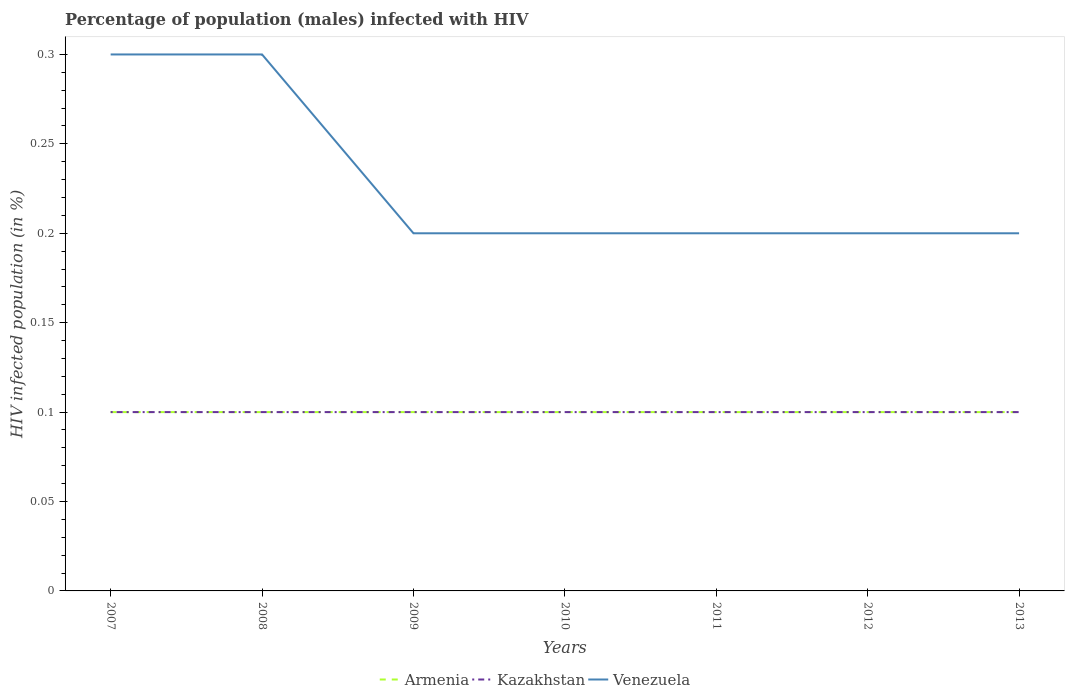Does the line corresponding to Venezuela intersect with the line corresponding to Kazakhstan?
Provide a succinct answer. No. In which year was the percentage of HIV infected male population in Armenia maximum?
Ensure brevity in your answer.  2007. Is the percentage of HIV infected male population in Venezuela strictly greater than the percentage of HIV infected male population in Armenia over the years?
Provide a short and direct response. No. How many lines are there?
Offer a very short reply. 3. How many years are there in the graph?
Provide a short and direct response. 7. Does the graph contain any zero values?
Offer a terse response. No. Does the graph contain grids?
Your answer should be compact. No. What is the title of the graph?
Keep it short and to the point. Percentage of population (males) infected with HIV. Does "Afghanistan" appear as one of the legend labels in the graph?
Your answer should be compact. No. What is the label or title of the Y-axis?
Keep it short and to the point. HIV infected population (in %). What is the HIV infected population (in %) in Armenia in 2007?
Your answer should be very brief. 0.1. What is the HIV infected population (in %) of Kazakhstan in 2007?
Offer a very short reply. 0.1. What is the HIV infected population (in %) of Venezuela in 2007?
Make the answer very short. 0.3. What is the HIV infected population (in %) of Armenia in 2008?
Provide a succinct answer. 0.1. What is the HIV infected population (in %) of Venezuela in 2008?
Your answer should be very brief. 0.3. What is the HIV infected population (in %) of Kazakhstan in 2010?
Offer a terse response. 0.1. What is the HIV infected population (in %) of Venezuela in 2010?
Your answer should be compact. 0.2. What is the HIV infected population (in %) in Kazakhstan in 2011?
Offer a terse response. 0.1. What is the HIV infected population (in %) of Kazakhstan in 2012?
Your response must be concise. 0.1. What is the HIV infected population (in %) in Kazakhstan in 2013?
Ensure brevity in your answer.  0.1. Across all years, what is the maximum HIV infected population (in %) in Kazakhstan?
Make the answer very short. 0.1. Across all years, what is the minimum HIV infected population (in %) of Venezuela?
Make the answer very short. 0.2. What is the total HIV infected population (in %) in Kazakhstan in the graph?
Ensure brevity in your answer.  0.7. What is the total HIV infected population (in %) in Venezuela in the graph?
Your response must be concise. 1.6. What is the difference between the HIV infected population (in %) of Armenia in 2007 and that in 2009?
Provide a short and direct response. 0. What is the difference between the HIV infected population (in %) in Kazakhstan in 2007 and that in 2009?
Your response must be concise. 0. What is the difference between the HIV infected population (in %) in Venezuela in 2007 and that in 2009?
Offer a very short reply. 0.1. What is the difference between the HIV infected population (in %) in Armenia in 2007 and that in 2010?
Provide a short and direct response. 0. What is the difference between the HIV infected population (in %) of Armenia in 2007 and that in 2011?
Provide a short and direct response. 0. What is the difference between the HIV infected population (in %) of Venezuela in 2007 and that in 2012?
Provide a succinct answer. 0.1. What is the difference between the HIV infected population (in %) in Armenia in 2007 and that in 2013?
Offer a very short reply. 0. What is the difference between the HIV infected population (in %) in Kazakhstan in 2007 and that in 2013?
Make the answer very short. 0. What is the difference between the HIV infected population (in %) in Armenia in 2008 and that in 2009?
Your response must be concise. 0. What is the difference between the HIV infected population (in %) in Venezuela in 2008 and that in 2009?
Offer a terse response. 0.1. What is the difference between the HIV infected population (in %) in Armenia in 2008 and that in 2010?
Give a very brief answer. 0. What is the difference between the HIV infected population (in %) of Venezuela in 2008 and that in 2010?
Keep it short and to the point. 0.1. What is the difference between the HIV infected population (in %) of Venezuela in 2008 and that in 2011?
Make the answer very short. 0.1. What is the difference between the HIV infected population (in %) of Kazakhstan in 2008 and that in 2012?
Keep it short and to the point. 0. What is the difference between the HIV infected population (in %) of Armenia in 2008 and that in 2013?
Offer a very short reply. 0. What is the difference between the HIV infected population (in %) in Kazakhstan in 2008 and that in 2013?
Give a very brief answer. 0. What is the difference between the HIV infected population (in %) in Armenia in 2009 and that in 2010?
Your answer should be very brief. 0. What is the difference between the HIV infected population (in %) of Venezuela in 2009 and that in 2010?
Give a very brief answer. 0. What is the difference between the HIV infected population (in %) in Armenia in 2009 and that in 2011?
Ensure brevity in your answer.  0. What is the difference between the HIV infected population (in %) in Kazakhstan in 2009 and that in 2011?
Your answer should be compact. 0. What is the difference between the HIV infected population (in %) in Armenia in 2009 and that in 2013?
Provide a succinct answer. 0. What is the difference between the HIV infected population (in %) of Venezuela in 2009 and that in 2013?
Give a very brief answer. 0. What is the difference between the HIV infected population (in %) of Kazakhstan in 2010 and that in 2011?
Offer a terse response. 0. What is the difference between the HIV infected population (in %) in Venezuela in 2010 and that in 2011?
Your response must be concise. 0. What is the difference between the HIV infected population (in %) in Venezuela in 2010 and that in 2012?
Your response must be concise. 0. What is the difference between the HIV infected population (in %) in Armenia in 2010 and that in 2013?
Give a very brief answer. 0. What is the difference between the HIV infected population (in %) in Venezuela in 2010 and that in 2013?
Keep it short and to the point. 0. What is the difference between the HIV infected population (in %) in Armenia in 2011 and that in 2013?
Your answer should be very brief. 0. What is the difference between the HIV infected population (in %) in Armenia in 2012 and that in 2013?
Your answer should be very brief. 0. What is the difference between the HIV infected population (in %) in Kazakhstan in 2012 and that in 2013?
Offer a very short reply. 0. What is the difference between the HIV infected population (in %) of Venezuela in 2012 and that in 2013?
Provide a short and direct response. 0. What is the difference between the HIV infected population (in %) in Armenia in 2007 and the HIV infected population (in %) in Kazakhstan in 2009?
Keep it short and to the point. 0. What is the difference between the HIV infected population (in %) of Kazakhstan in 2007 and the HIV infected population (in %) of Venezuela in 2009?
Ensure brevity in your answer.  -0.1. What is the difference between the HIV infected population (in %) in Armenia in 2007 and the HIV infected population (in %) in Venezuela in 2011?
Keep it short and to the point. -0.1. What is the difference between the HIV infected population (in %) of Armenia in 2007 and the HIV infected population (in %) of Venezuela in 2012?
Keep it short and to the point. -0.1. What is the difference between the HIV infected population (in %) in Armenia in 2007 and the HIV infected population (in %) in Kazakhstan in 2013?
Your response must be concise. 0. What is the difference between the HIV infected population (in %) of Armenia in 2007 and the HIV infected population (in %) of Venezuela in 2013?
Offer a very short reply. -0.1. What is the difference between the HIV infected population (in %) of Kazakhstan in 2007 and the HIV infected population (in %) of Venezuela in 2013?
Offer a terse response. -0.1. What is the difference between the HIV infected population (in %) in Armenia in 2008 and the HIV infected population (in %) in Kazakhstan in 2010?
Keep it short and to the point. 0. What is the difference between the HIV infected population (in %) of Kazakhstan in 2008 and the HIV infected population (in %) of Venezuela in 2010?
Your answer should be very brief. -0.1. What is the difference between the HIV infected population (in %) in Kazakhstan in 2008 and the HIV infected population (in %) in Venezuela in 2011?
Provide a succinct answer. -0.1. What is the difference between the HIV infected population (in %) of Armenia in 2008 and the HIV infected population (in %) of Venezuela in 2012?
Your answer should be compact. -0.1. What is the difference between the HIV infected population (in %) of Kazakhstan in 2008 and the HIV infected population (in %) of Venezuela in 2012?
Make the answer very short. -0.1. What is the difference between the HIV infected population (in %) in Armenia in 2008 and the HIV infected population (in %) in Venezuela in 2013?
Keep it short and to the point. -0.1. What is the difference between the HIV infected population (in %) of Armenia in 2009 and the HIV infected population (in %) of Kazakhstan in 2010?
Give a very brief answer. 0. What is the difference between the HIV infected population (in %) of Armenia in 2009 and the HIV infected population (in %) of Venezuela in 2010?
Ensure brevity in your answer.  -0.1. What is the difference between the HIV infected population (in %) in Kazakhstan in 2009 and the HIV infected population (in %) in Venezuela in 2010?
Give a very brief answer. -0.1. What is the difference between the HIV infected population (in %) in Armenia in 2009 and the HIV infected population (in %) in Kazakhstan in 2011?
Give a very brief answer. 0. What is the difference between the HIV infected population (in %) of Kazakhstan in 2009 and the HIV infected population (in %) of Venezuela in 2011?
Your answer should be very brief. -0.1. What is the difference between the HIV infected population (in %) in Armenia in 2009 and the HIV infected population (in %) in Venezuela in 2012?
Your answer should be very brief. -0.1. What is the difference between the HIV infected population (in %) in Kazakhstan in 2009 and the HIV infected population (in %) in Venezuela in 2012?
Your response must be concise. -0.1. What is the difference between the HIV infected population (in %) of Armenia in 2009 and the HIV infected population (in %) of Kazakhstan in 2013?
Give a very brief answer. 0. What is the difference between the HIV infected population (in %) in Armenia in 2009 and the HIV infected population (in %) in Venezuela in 2013?
Keep it short and to the point. -0.1. What is the difference between the HIV infected population (in %) of Armenia in 2010 and the HIV infected population (in %) of Kazakhstan in 2011?
Offer a very short reply. 0. What is the difference between the HIV infected population (in %) of Kazakhstan in 2010 and the HIV infected population (in %) of Venezuela in 2011?
Your answer should be very brief. -0.1. What is the difference between the HIV infected population (in %) of Armenia in 2010 and the HIV infected population (in %) of Kazakhstan in 2012?
Make the answer very short. 0. What is the difference between the HIV infected population (in %) in Armenia in 2010 and the HIV infected population (in %) in Venezuela in 2012?
Offer a terse response. -0.1. What is the difference between the HIV infected population (in %) in Kazakhstan in 2010 and the HIV infected population (in %) in Venezuela in 2013?
Your answer should be very brief. -0.1. What is the difference between the HIV infected population (in %) of Kazakhstan in 2011 and the HIV infected population (in %) of Venezuela in 2012?
Offer a very short reply. -0.1. What is the difference between the HIV infected population (in %) of Armenia in 2011 and the HIV infected population (in %) of Kazakhstan in 2013?
Provide a short and direct response. 0. What is the difference between the HIV infected population (in %) in Armenia in 2011 and the HIV infected population (in %) in Venezuela in 2013?
Keep it short and to the point. -0.1. What is the difference between the HIV infected population (in %) of Kazakhstan in 2011 and the HIV infected population (in %) of Venezuela in 2013?
Ensure brevity in your answer.  -0.1. What is the difference between the HIV infected population (in %) in Armenia in 2012 and the HIV infected population (in %) in Kazakhstan in 2013?
Offer a very short reply. 0. What is the difference between the HIV infected population (in %) of Kazakhstan in 2012 and the HIV infected population (in %) of Venezuela in 2013?
Provide a short and direct response. -0.1. What is the average HIV infected population (in %) of Kazakhstan per year?
Provide a succinct answer. 0.1. What is the average HIV infected population (in %) in Venezuela per year?
Offer a terse response. 0.23. In the year 2007, what is the difference between the HIV infected population (in %) in Armenia and HIV infected population (in %) in Kazakhstan?
Provide a succinct answer. 0. In the year 2007, what is the difference between the HIV infected population (in %) in Armenia and HIV infected population (in %) in Venezuela?
Ensure brevity in your answer.  -0.2. In the year 2007, what is the difference between the HIV infected population (in %) of Kazakhstan and HIV infected population (in %) of Venezuela?
Give a very brief answer. -0.2. In the year 2008, what is the difference between the HIV infected population (in %) of Armenia and HIV infected population (in %) of Kazakhstan?
Provide a succinct answer. 0. In the year 2009, what is the difference between the HIV infected population (in %) in Armenia and HIV infected population (in %) in Kazakhstan?
Your answer should be very brief. 0. In the year 2009, what is the difference between the HIV infected population (in %) of Armenia and HIV infected population (in %) of Venezuela?
Offer a terse response. -0.1. In the year 2012, what is the difference between the HIV infected population (in %) in Armenia and HIV infected population (in %) in Kazakhstan?
Make the answer very short. 0. In the year 2012, what is the difference between the HIV infected population (in %) of Armenia and HIV infected population (in %) of Venezuela?
Your answer should be compact. -0.1. In the year 2012, what is the difference between the HIV infected population (in %) in Kazakhstan and HIV infected population (in %) in Venezuela?
Provide a succinct answer. -0.1. In the year 2013, what is the difference between the HIV infected population (in %) of Kazakhstan and HIV infected population (in %) of Venezuela?
Your answer should be compact. -0.1. What is the ratio of the HIV infected population (in %) in Armenia in 2007 to that in 2008?
Offer a terse response. 1. What is the ratio of the HIV infected population (in %) in Kazakhstan in 2007 to that in 2009?
Your response must be concise. 1. What is the ratio of the HIV infected population (in %) in Kazakhstan in 2007 to that in 2011?
Provide a short and direct response. 1. What is the ratio of the HIV infected population (in %) of Venezuela in 2007 to that in 2011?
Offer a very short reply. 1.5. What is the ratio of the HIV infected population (in %) in Armenia in 2007 to that in 2012?
Provide a short and direct response. 1. What is the ratio of the HIV infected population (in %) of Armenia in 2007 to that in 2013?
Offer a very short reply. 1. What is the ratio of the HIV infected population (in %) of Kazakhstan in 2007 to that in 2013?
Your response must be concise. 1. What is the ratio of the HIV infected population (in %) in Venezuela in 2007 to that in 2013?
Provide a short and direct response. 1.5. What is the ratio of the HIV infected population (in %) in Armenia in 2008 to that in 2010?
Your answer should be compact. 1. What is the ratio of the HIV infected population (in %) in Venezuela in 2008 to that in 2010?
Offer a terse response. 1.5. What is the ratio of the HIV infected population (in %) in Armenia in 2008 to that in 2012?
Your answer should be very brief. 1. What is the ratio of the HIV infected population (in %) of Kazakhstan in 2008 to that in 2012?
Your answer should be very brief. 1. What is the ratio of the HIV infected population (in %) of Armenia in 2008 to that in 2013?
Offer a very short reply. 1. What is the ratio of the HIV infected population (in %) of Kazakhstan in 2008 to that in 2013?
Offer a very short reply. 1. What is the ratio of the HIV infected population (in %) of Venezuela in 2008 to that in 2013?
Offer a very short reply. 1.5. What is the ratio of the HIV infected population (in %) of Kazakhstan in 2009 to that in 2010?
Make the answer very short. 1. What is the ratio of the HIV infected population (in %) in Venezuela in 2009 to that in 2010?
Your answer should be compact. 1. What is the ratio of the HIV infected population (in %) in Armenia in 2009 to that in 2011?
Offer a very short reply. 1. What is the ratio of the HIV infected population (in %) of Kazakhstan in 2009 to that in 2011?
Your answer should be compact. 1. What is the ratio of the HIV infected population (in %) in Kazakhstan in 2009 to that in 2012?
Give a very brief answer. 1. What is the ratio of the HIV infected population (in %) of Kazakhstan in 2009 to that in 2013?
Your response must be concise. 1. What is the ratio of the HIV infected population (in %) in Venezuela in 2009 to that in 2013?
Give a very brief answer. 1. What is the ratio of the HIV infected population (in %) in Armenia in 2010 to that in 2011?
Give a very brief answer. 1. What is the ratio of the HIV infected population (in %) of Kazakhstan in 2010 to that in 2011?
Give a very brief answer. 1. What is the ratio of the HIV infected population (in %) in Venezuela in 2010 to that in 2011?
Your answer should be compact. 1. What is the ratio of the HIV infected population (in %) in Armenia in 2010 to that in 2012?
Your answer should be compact. 1. What is the ratio of the HIV infected population (in %) of Kazakhstan in 2010 to that in 2012?
Keep it short and to the point. 1. What is the ratio of the HIV infected population (in %) of Venezuela in 2010 to that in 2012?
Offer a very short reply. 1. What is the ratio of the HIV infected population (in %) of Venezuela in 2010 to that in 2013?
Give a very brief answer. 1. What is the ratio of the HIV infected population (in %) of Armenia in 2011 to that in 2012?
Your response must be concise. 1. What is the ratio of the HIV infected population (in %) in Kazakhstan in 2011 to that in 2012?
Offer a terse response. 1. What is the ratio of the HIV infected population (in %) in Kazakhstan in 2011 to that in 2013?
Give a very brief answer. 1. What is the ratio of the HIV infected population (in %) of Venezuela in 2011 to that in 2013?
Make the answer very short. 1. What is the ratio of the HIV infected population (in %) in Kazakhstan in 2012 to that in 2013?
Provide a short and direct response. 1. What is the ratio of the HIV infected population (in %) in Venezuela in 2012 to that in 2013?
Make the answer very short. 1. What is the difference between the highest and the second highest HIV infected population (in %) in Armenia?
Make the answer very short. 0. What is the difference between the highest and the second highest HIV infected population (in %) of Kazakhstan?
Offer a terse response. 0. What is the difference between the highest and the lowest HIV infected population (in %) in Kazakhstan?
Ensure brevity in your answer.  0. 